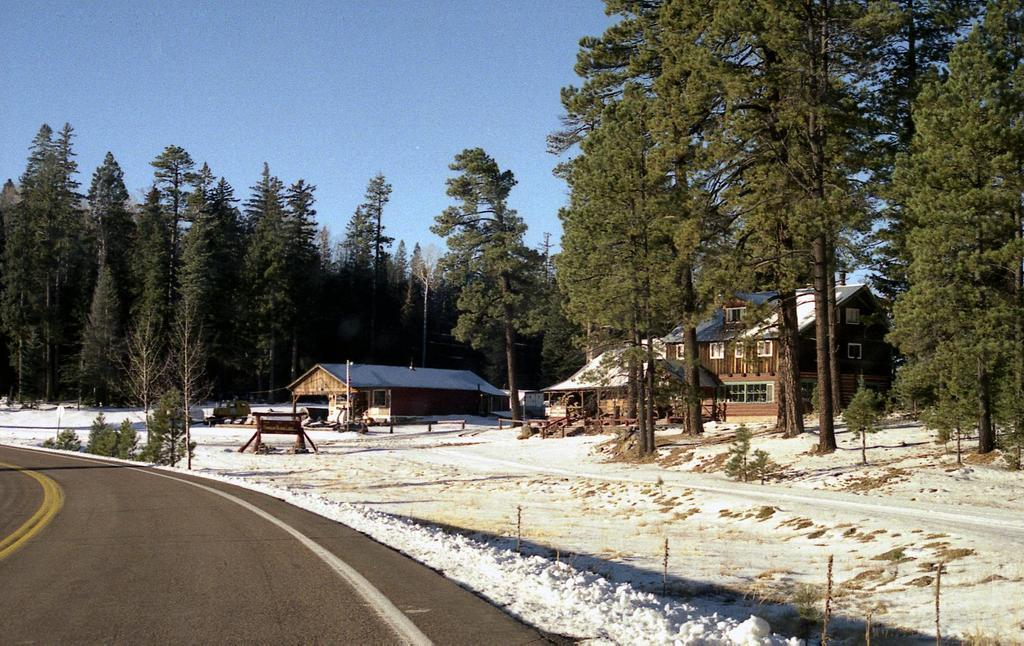What type of vegetation is present in the image? There are many trees in the image. What structures can be seen in the image? There are buildings in the image, and their windows are visible. What is the color of the snow in the image? The snow is white in color. What is the color of the sky in the image? The sky is blue in the image. What type of pathway is present in the image? There is a road in the image, and it has white and yellow lines on it. Can you tell me how many crackers are on the roof of the building in the image? There are no crackers present in the image; it features trees, buildings, snow, a road, and a blue sky. What type of bird is sitting on the wren in the image? There is no wren present in the image, as the provided facts only mention trees, buildings, snow, a road, and a blue sky. 